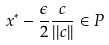Convert formula to latex. <formula><loc_0><loc_0><loc_500><loc_500>x ^ { * } - \frac { \epsilon } { 2 } \frac { c } { | | c | | } \in P</formula> 